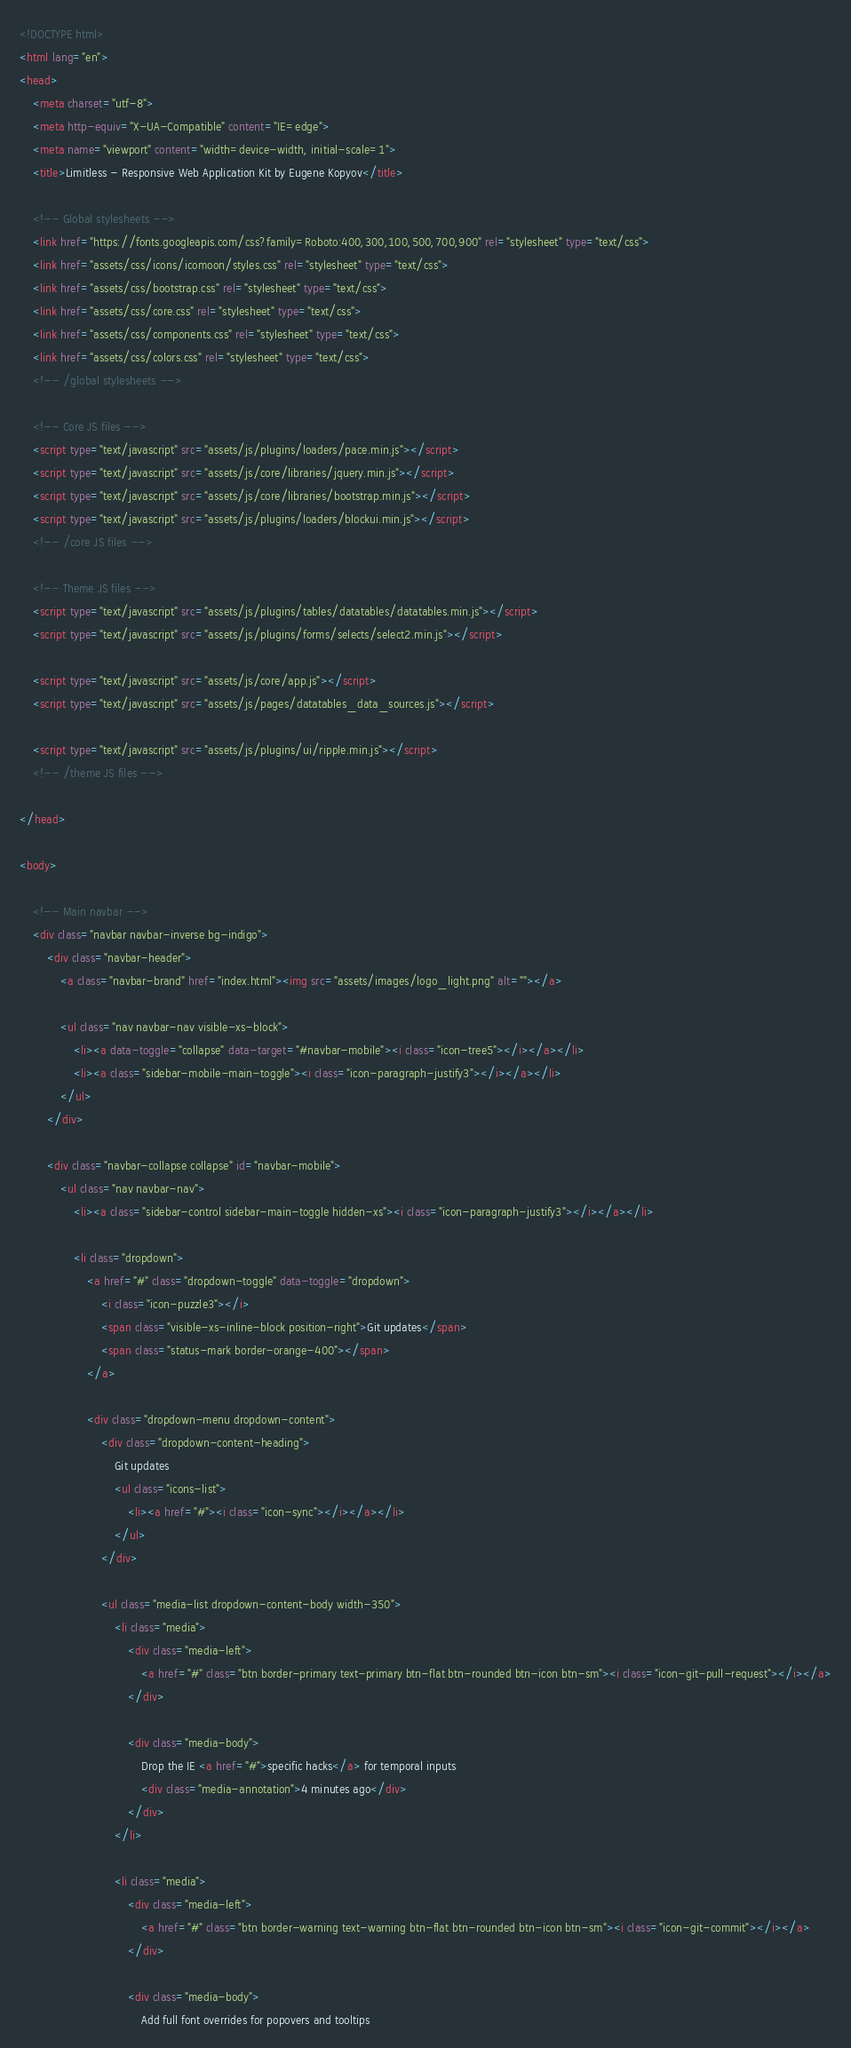Convert code to text. <code><loc_0><loc_0><loc_500><loc_500><_HTML_><!DOCTYPE html>
<html lang="en">
<head>
	<meta charset="utf-8">
	<meta http-equiv="X-UA-Compatible" content="IE=edge">
	<meta name="viewport" content="width=device-width, initial-scale=1">
	<title>Limitless - Responsive Web Application Kit by Eugene Kopyov</title>

	<!-- Global stylesheets -->
	<link href="https://fonts.googleapis.com/css?family=Roboto:400,300,100,500,700,900" rel="stylesheet" type="text/css">
	<link href="assets/css/icons/icomoon/styles.css" rel="stylesheet" type="text/css">
	<link href="assets/css/bootstrap.css" rel="stylesheet" type="text/css">
	<link href="assets/css/core.css" rel="stylesheet" type="text/css">
	<link href="assets/css/components.css" rel="stylesheet" type="text/css">
	<link href="assets/css/colors.css" rel="stylesheet" type="text/css">
	<!-- /global stylesheets -->

	<!-- Core JS files -->
	<script type="text/javascript" src="assets/js/plugins/loaders/pace.min.js"></script>
	<script type="text/javascript" src="assets/js/core/libraries/jquery.min.js"></script>
	<script type="text/javascript" src="assets/js/core/libraries/bootstrap.min.js"></script>
	<script type="text/javascript" src="assets/js/plugins/loaders/blockui.min.js"></script>
	<!-- /core JS files -->

	<!-- Theme JS files -->
	<script type="text/javascript" src="assets/js/plugins/tables/datatables/datatables.min.js"></script>
	<script type="text/javascript" src="assets/js/plugins/forms/selects/select2.min.js"></script>

	<script type="text/javascript" src="assets/js/core/app.js"></script>
	<script type="text/javascript" src="assets/js/pages/datatables_data_sources.js"></script>

	<script type="text/javascript" src="assets/js/plugins/ui/ripple.min.js"></script>
	<!-- /theme JS files -->

</head>

<body>

	<!-- Main navbar -->
	<div class="navbar navbar-inverse bg-indigo">
		<div class="navbar-header">
			<a class="navbar-brand" href="index.html"><img src="assets/images/logo_light.png" alt=""></a>

			<ul class="nav navbar-nav visible-xs-block">
				<li><a data-toggle="collapse" data-target="#navbar-mobile"><i class="icon-tree5"></i></a></li>
				<li><a class="sidebar-mobile-main-toggle"><i class="icon-paragraph-justify3"></i></a></li>
			</ul>
		</div>

		<div class="navbar-collapse collapse" id="navbar-mobile">
			<ul class="nav navbar-nav">
				<li><a class="sidebar-control sidebar-main-toggle hidden-xs"><i class="icon-paragraph-justify3"></i></a></li>

				<li class="dropdown">
					<a href="#" class="dropdown-toggle" data-toggle="dropdown">
						<i class="icon-puzzle3"></i>
						<span class="visible-xs-inline-block position-right">Git updates</span>
						<span class="status-mark border-orange-400"></span>
					</a>
					
					<div class="dropdown-menu dropdown-content">
						<div class="dropdown-content-heading">
							Git updates
							<ul class="icons-list">
								<li><a href="#"><i class="icon-sync"></i></a></li>
							</ul>
						</div>

						<ul class="media-list dropdown-content-body width-350">
							<li class="media">
								<div class="media-left">
									<a href="#" class="btn border-primary text-primary btn-flat btn-rounded btn-icon btn-sm"><i class="icon-git-pull-request"></i></a>
								</div>

								<div class="media-body">
									Drop the IE <a href="#">specific hacks</a> for temporal inputs
									<div class="media-annotation">4 minutes ago</div>
								</div>
							</li>

							<li class="media">
								<div class="media-left">
									<a href="#" class="btn border-warning text-warning btn-flat btn-rounded btn-icon btn-sm"><i class="icon-git-commit"></i></a>
								</div>
								
								<div class="media-body">
									Add full font overrides for popovers and tooltips</code> 